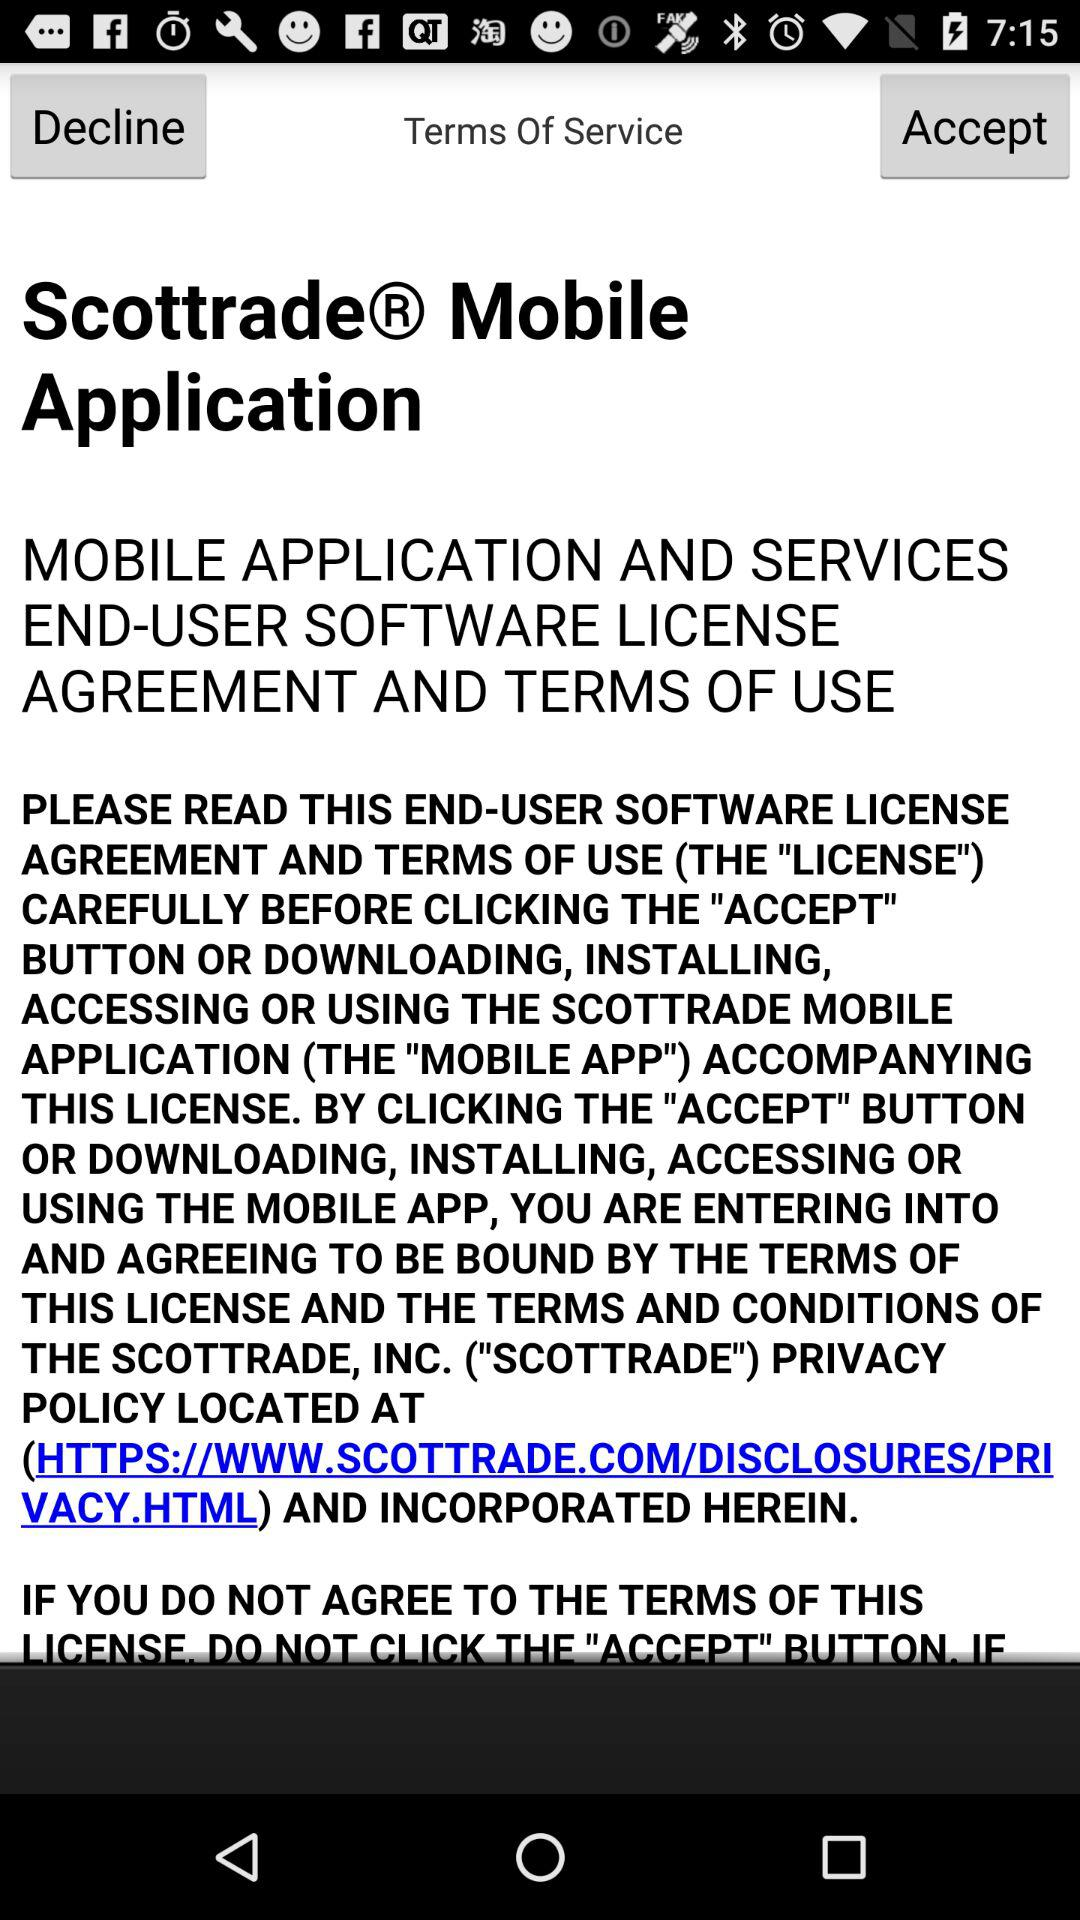Has the user agreed to the terms of service?
When the provided information is insufficient, respond with <no answer>. <no answer> 